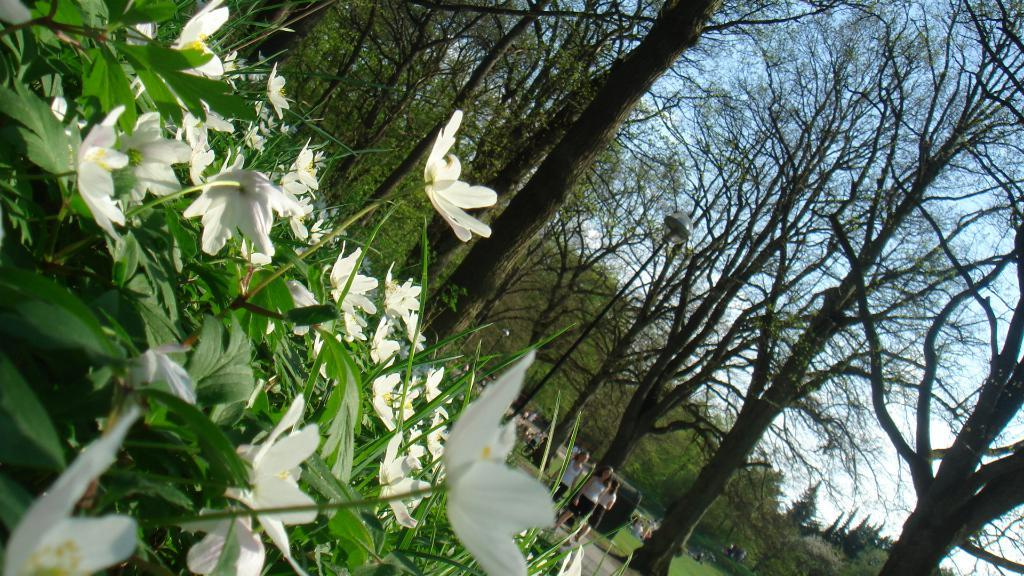What type of flowers can be seen in the left corner of the image? There are white color flowers in the left corner of the image. What else is present in the right corner of the image? There are persons in the right corner of the image. What can be seen in the background of the image? There are trees in the background of the image. What type of government is depicted in the image? There is no depiction of a government in the image; it features flowers, persons, and trees. What time of day is it in the image? The time of day cannot be determined from the image, as there are no specific clues or indicators present. 